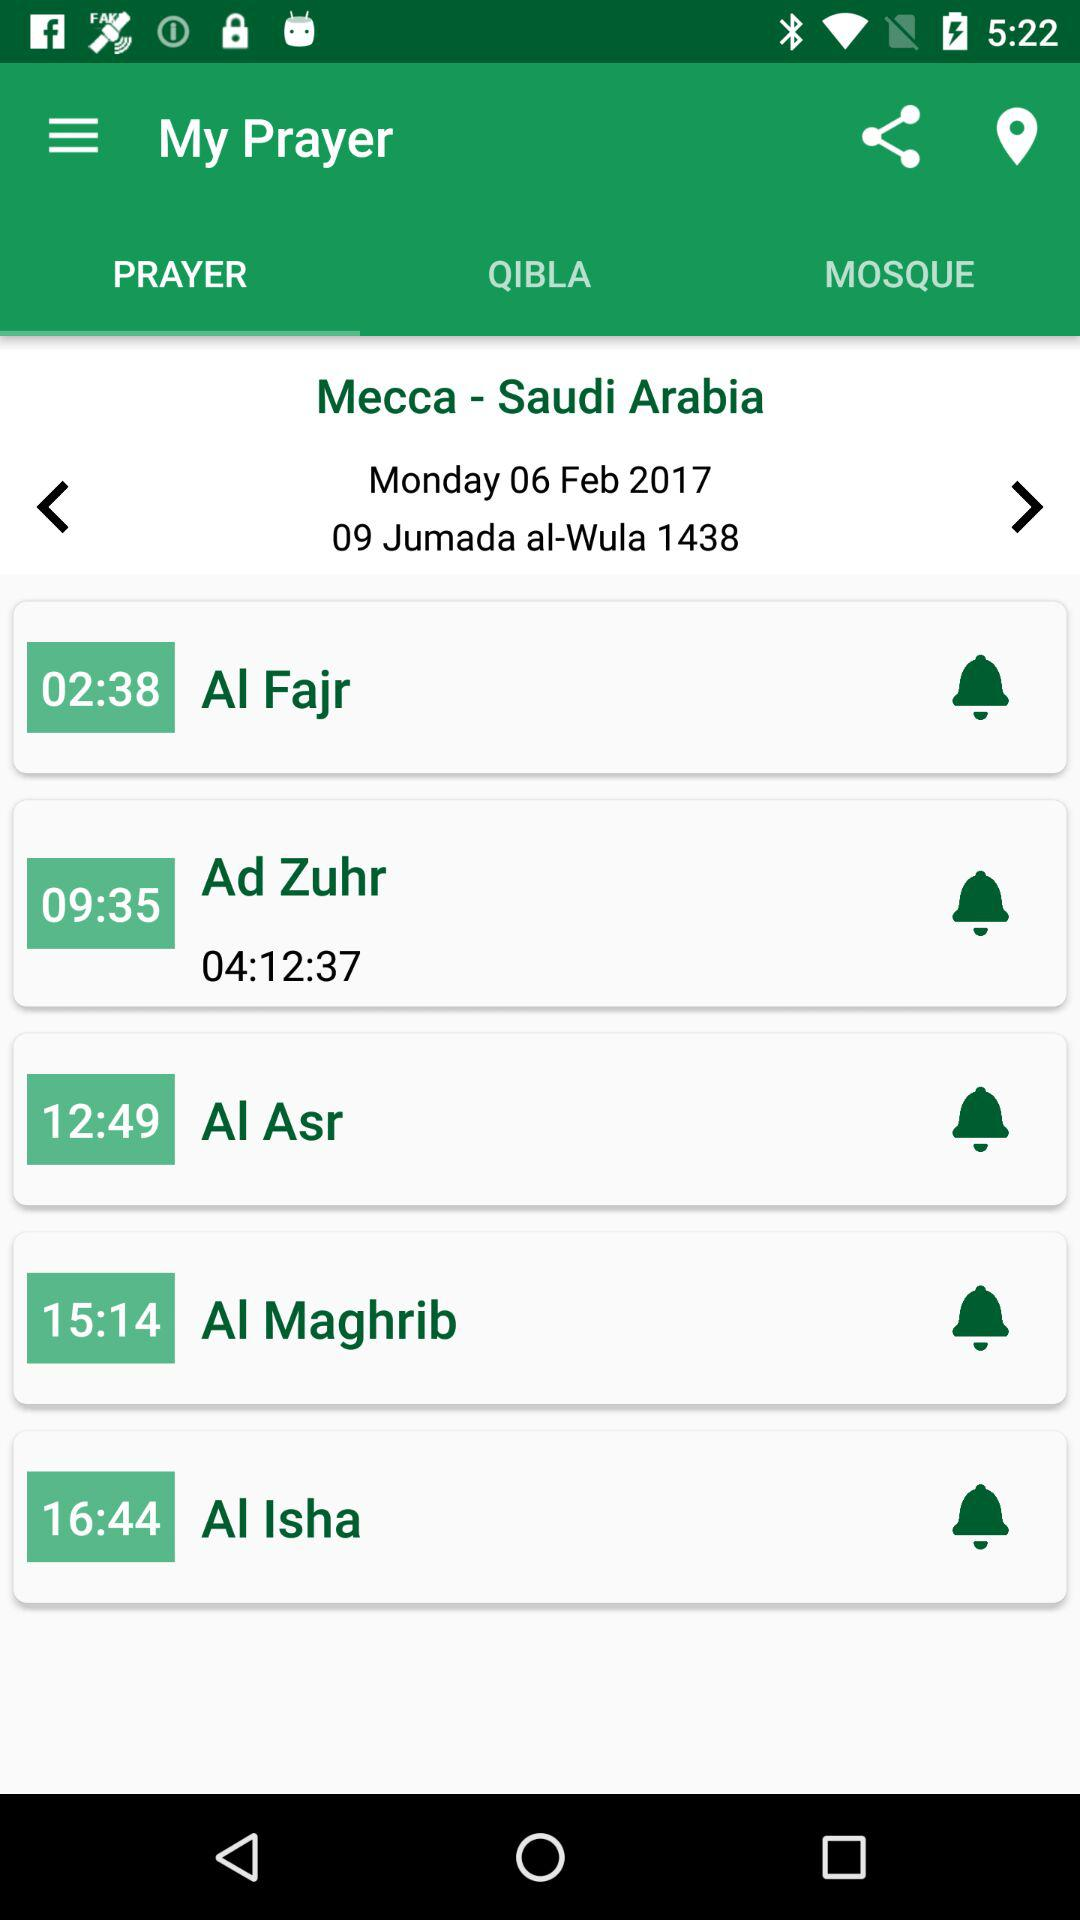Which tab is selected? The selected tab is "PRAYER". 